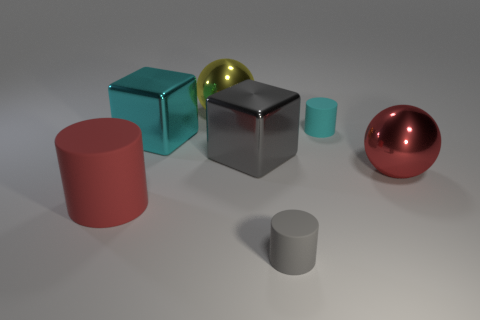Subtract all big rubber cylinders. How many cylinders are left? 2 Subtract all red cylinders. How many cylinders are left? 2 Add 2 tiny purple cylinders. How many objects exist? 9 Subtract all cylinders. How many objects are left? 4 Subtract 1 cylinders. How many cylinders are left? 2 Subtract all cyan cylinders. Subtract all green cubes. How many cylinders are left? 2 Subtract all red cylinders. How many brown balls are left? 0 Subtract all red metallic things. Subtract all small cyan matte blocks. How many objects are left? 6 Add 7 large red rubber things. How many large red rubber things are left? 8 Add 3 green shiny objects. How many green shiny objects exist? 3 